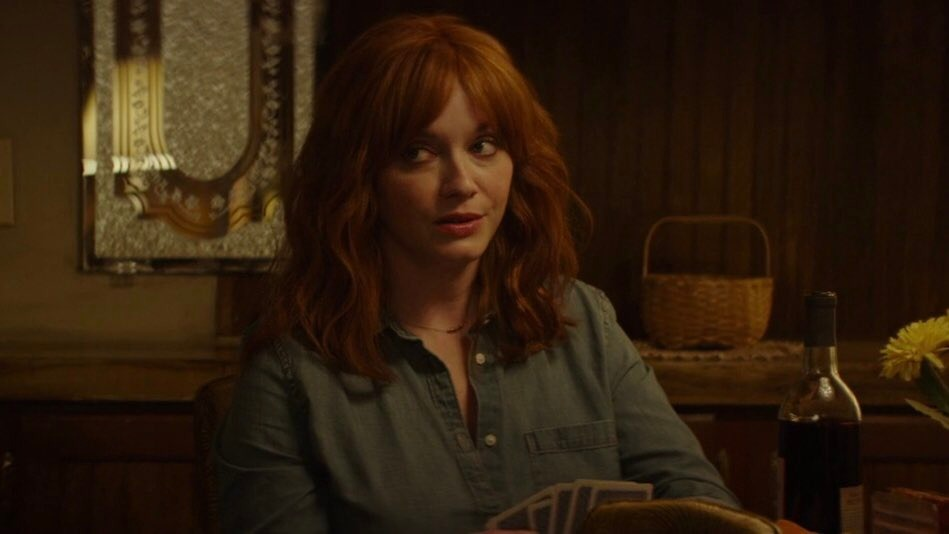Can you describe what emotions the person in the image might be experiencing? The individual seems to be experiencing a mix of curiosity and mild confusion. The slight furrow of the brows and the directed, somewhat distant gaze suggest she might be contemplating a recent event or pondering over a perplexing situation. The relaxed yet attentive posture also hints at a moment of reflective thought. 